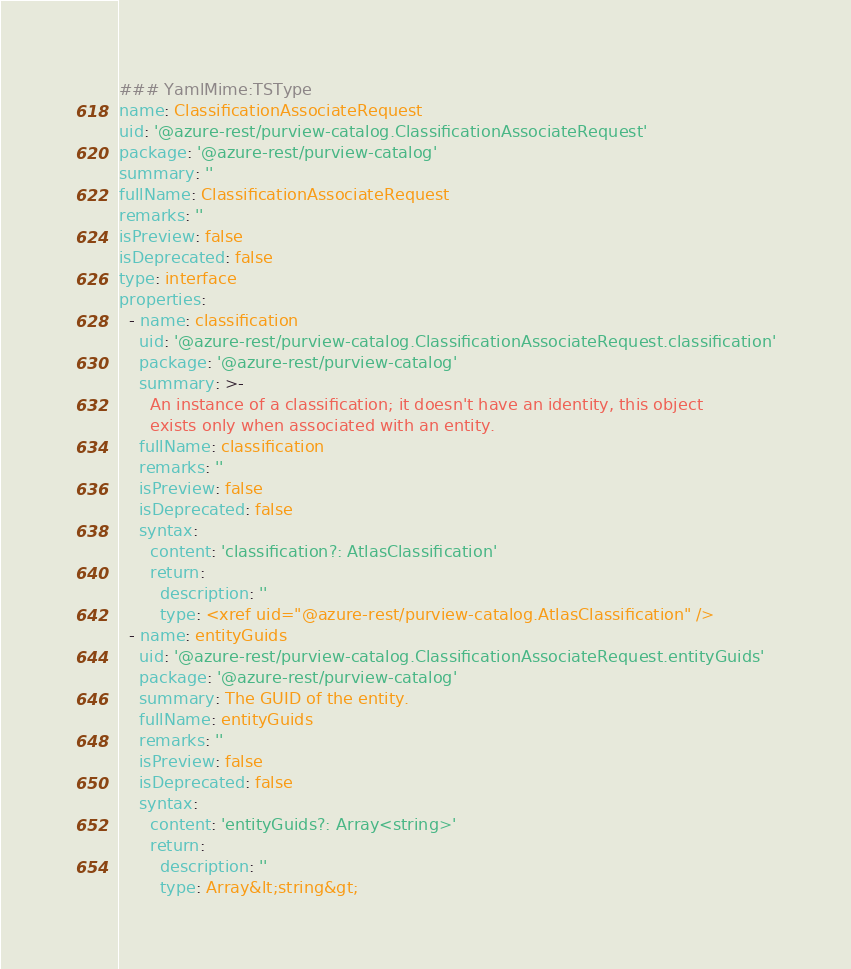Convert code to text. <code><loc_0><loc_0><loc_500><loc_500><_YAML_>### YamlMime:TSType
name: ClassificationAssociateRequest
uid: '@azure-rest/purview-catalog.ClassificationAssociateRequest'
package: '@azure-rest/purview-catalog'
summary: ''
fullName: ClassificationAssociateRequest
remarks: ''
isPreview: false
isDeprecated: false
type: interface
properties:
  - name: classification
    uid: '@azure-rest/purview-catalog.ClassificationAssociateRequest.classification'
    package: '@azure-rest/purview-catalog'
    summary: >-
      An instance of a classification; it doesn't have an identity, this object
      exists only when associated with an entity.
    fullName: classification
    remarks: ''
    isPreview: false
    isDeprecated: false
    syntax:
      content: 'classification?: AtlasClassification'
      return:
        description: ''
        type: <xref uid="@azure-rest/purview-catalog.AtlasClassification" />
  - name: entityGuids
    uid: '@azure-rest/purview-catalog.ClassificationAssociateRequest.entityGuids'
    package: '@azure-rest/purview-catalog'
    summary: The GUID of the entity.
    fullName: entityGuids
    remarks: ''
    isPreview: false
    isDeprecated: false
    syntax:
      content: 'entityGuids?: Array<string>'
      return:
        description: ''
        type: Array&lt;string&gt;
</code> 